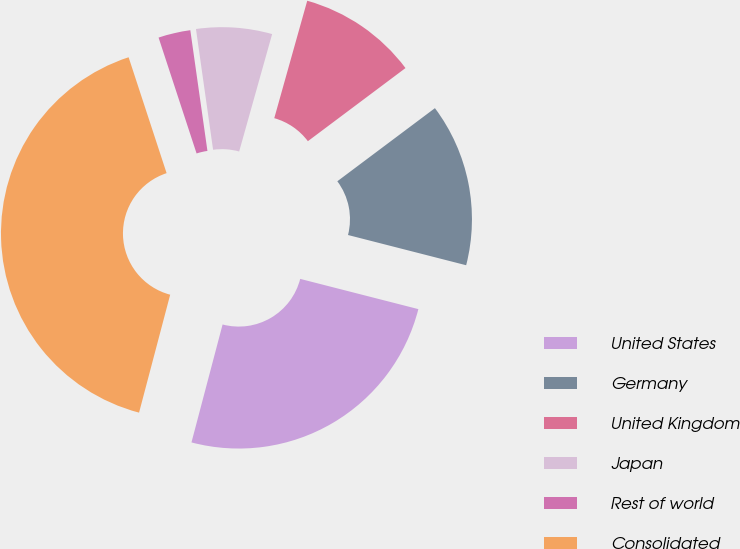<chart> <loc_0><loc_0><loc_500><loc_500><pie_chart><fcel>United States<fcel>Germany<fcel>United Kingdom<fcel>Japan<fcel>Rest of world<fcel>Consolidated<nl><fcel>25.12%<fcel>14.22%<fcel>10.41%<fcel>6.6%<fcel>2.8%<fcel>40.85%<nl></chart> 